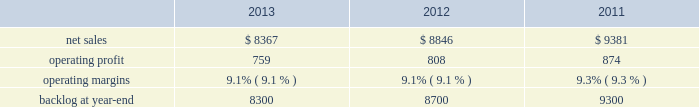Aeronautics 2019 operating profit for 2012 increased $ 69 million , or 4% ( 4 % ) , compared to 2011 .
The increase was attributable to higher operating profit of approximately $ 105 million from c-130 programs due to an increase in risk retirements ; about $ 50 million from f-16 programs due to higher aircraft deliveries partially offset by a decline in risk retirements ; approximately $ 50 million from f-35 production contracts due to increased production volume and risk retirements ; and about $ 50 million from the completion of purchased intangible asset amortization on certain f-16 contracts .
Partially offsetting the increases was lower operating profit of about $ 90 million from the f-35 development contract primarily due to the inception-to-date effect of reducing the profit booking rate in the second quarter of 2012 ; approximately $ 50 million from decreased production volume and risk retirements on the f-22 program partially offset by a resolution of a contractual matter in the second quarter of 2012 ; and approximately $ 45 million primarily due to a decrease in risk retirements on other sustainment activities partially offset by various other aeronautics programs due to increased risk retirements and volume .
Operating profit for c-5 programs was comparable to 2011 .
Adjustments not related to volume , including net profit booking rate adjustments and other matters described above , were approximately $ 30 million lower for 2012 compared to 2011 .
Backlog backlog decreased in 2013 compared to 2012 mainly due to lower orders on f-16 , c-5 , and c-130 programs , partially offset by higher orders on the f-35 program .
Backlog decreased in 2012 compared to 2011 mainly due to lower orders on f-35 and c-130 programs , partially offset by higher orders on f-16 programs .
Trends we expect aeronautics 2019 net sales to increase in 2014 in the mid-single digit percentage range as compared to 2013 primarily due to an increase in net sales from f-35 production contracts .
Operating profit is expected to increase slightly from 2013 , resulting in a slight decrease in operating margins between the years due to program mix .
Information systems & global solutions our is&gs business segment provides advanced technology systems and expertise , integrated information technology solutions , and management services across a broad spectrum of applications for civil , defense , intelligence , and other government customers .
Is&gs has a portfolio of many smaller contracts as compared to our other business segments .
Is&gs has been impacted by the continued downturn in federal information technology budgets .
Is&gs 2019 operating results included the following ( in millions ) : .
2013 compared to 2012 is&gs 2019 net sales decreased $ 479 million , or 5% ( 5 % ) , for 2013 compared to 2012 .
The decrease was attributable to lower net sales of about $ 495 million due to decreased volume on various programs ( command and control programs for classified customers , ngi , and eram programs ) ; and approximately $ 320 million due to the completion of certain programs ( such as total information processing support services , the transportation worker identification credential ( twic ) , and odin ) .
The decrease was partially offset by higher net sales of about $ 340 million due to the start-up of certain programs ( such as the disa gsm-o and the national science foundation antarctic support ) .
Is&gs 2019 operating profit decreased $ 49 million , or 6% ( 6 % ) , for 2013 compared to 2012 .
The decrease was primarily attributable to lower operating profit of about $ 55 million due to certain programs nearing the end of their lifecycles , partially offset by higher operating profit of approximately $ 15 million due to the start-up of certain programs .
Adjustments not related to volume , including net profit booking rate adjustments and other matters , were comparable for 2013 compared to 2012 compared to 2011 is&gs 2019 net sales for 2012 decreased $ 535 million , or 6% ( 6 % ) , compared to 2011 .
The decrease was attributable to lower net sales of approximately $ 485 million due to the substantial completion of various programs during 2011 ( primarily jtrs ; odin ; and u.k .
Census ) ; and about $ 255 million due to lower volume on numerous other programs ( primarily hanford; .
What were average net sales for is&gs from 2011 to 2013 , in millions? 
Computations: table_average(net sales, none)
Answer: 8864.66667. 